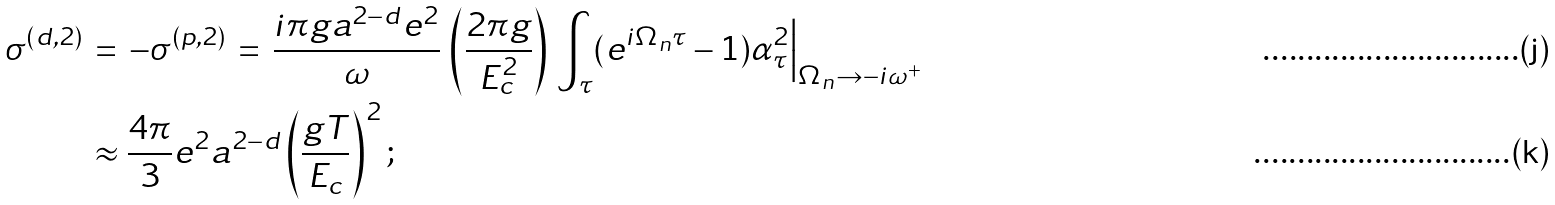<formula> <loc_0><loc_0><loc_500><loc_500>\sigma ^ { ( d , 2 ) } \, & = \, - \sigma ^ { ( p , 2 ) } \, = \, \frac { i \pi g a ^ { 2 - d } e ^ { 2 } } { \omega } \, \left ( \frac { 2 \pi g } { E _ { c } ^ { 2 } } \right ) \, \int _ { \tau } ( e ^ { i \Omega _ { n } \tau } - 1 ) \alpha _ { \tau } ^ { 2 } \Big | _ { \Omega _ { n } \rightarrow - i \omega ^ { + } } \, \\ & \approx \frac { 4 \pi } { 3 } e ^ { 2 } a ^ { 2 - d } \left ( \frac { g T } { E _ { c } } \right ) ^ { 2 } ;</formula> 